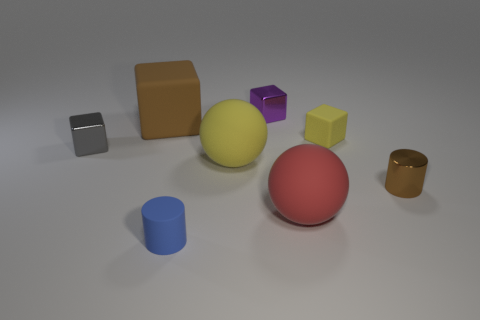What number of other objects are the same size as the brown metal cylinder?
Keep it short and to the point. 4. There is a big red object that is the same shape as the big yellow thing; what is it made of?
Make the answer very short. Rubber. There is a brown cylinder that is to the right of the small object behind the big matte block; how big is it?
Offer a terse response. Small. Are any large purple matte objects visible?
Your response must be concise. No. There is a thing that is left of the small blue object and in front of the brown matte block; what material is it made of?
Provide a succinct answer. Metal. Are there more small blue cylinders behind the big yellow thing than tiny cylinders that are behind the small brown metal object?
Your response must be concise. No. Is there a cyan rubber cylinder of the same size as the yellow rubber block?
Make the answer very short. No. There is a metallic thing that is in front of the shiny object that is on the left side of the matte object to the left of the blue cylinder; how big is it?
Offer a terse response. Small. What is the color of the small rubber cube?
Ensure brevity in your answer.  Yellow. Are there more small gray shiny things that are behind the gray block than big brown rubber things?
Keep it short and to the point. No. 